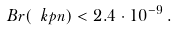<formula> <loc_0><loc_0><loc_500><loc_500>B r ( \ k p n ) < 2 . 4 \cdot 1 0 ^ { - 9 } \, .</formula> 